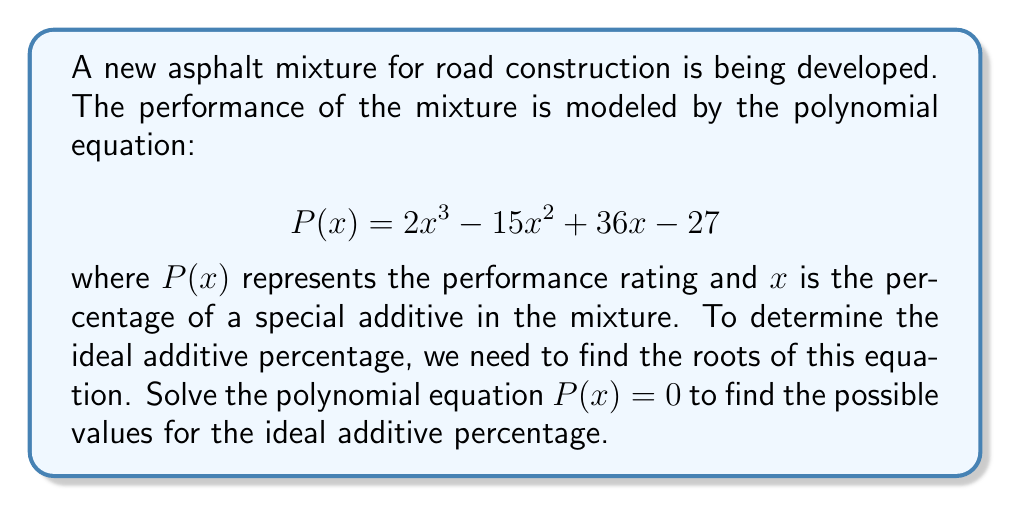Could you help me with this problem? To solve this polynomial equation, we'll use the following steps:

1) First, let's check if there are any rational roots using the rational root theorem. The possible rational roots are the factors of the constant term (27): ±1, ±3, ±9, ±27.

2) Testing these values, we find that x = 3 is a root of the equation.

3) We can factor out (x - 3):

   $$2x^3 - 15x^2 + 36x - 27 = (x - 3)(2x^2 - 9x + 9)$$

4) Now we need to solve the quadratic equation $2x^2 - 9x + 9 = 0$

5) We can solve this using the quadratic formula: $x = \frac{-b \pm \sqrt{b^2 - 4ac}}{2a}$

   Where $a = 2$, $b = -9$, and $c = 9$

6) Plugging in these values:

   $$x = \frac{9 \pm \sqrt{81 - 72}}{4} = \frac{9 \pm 3}{4}$$

7) This gives us two more solutions:

   $$x = \frac{9 + 3}{4} = 3$$ and $$x = \frac{9 - 3}{4} = \frac{3}{2}$$

Therefore, the roots of the equation are 3 (twice) and 1.5.
Answer: The possible values for the ideal additive percentage are 3% (repeated root) and 1.5%. 